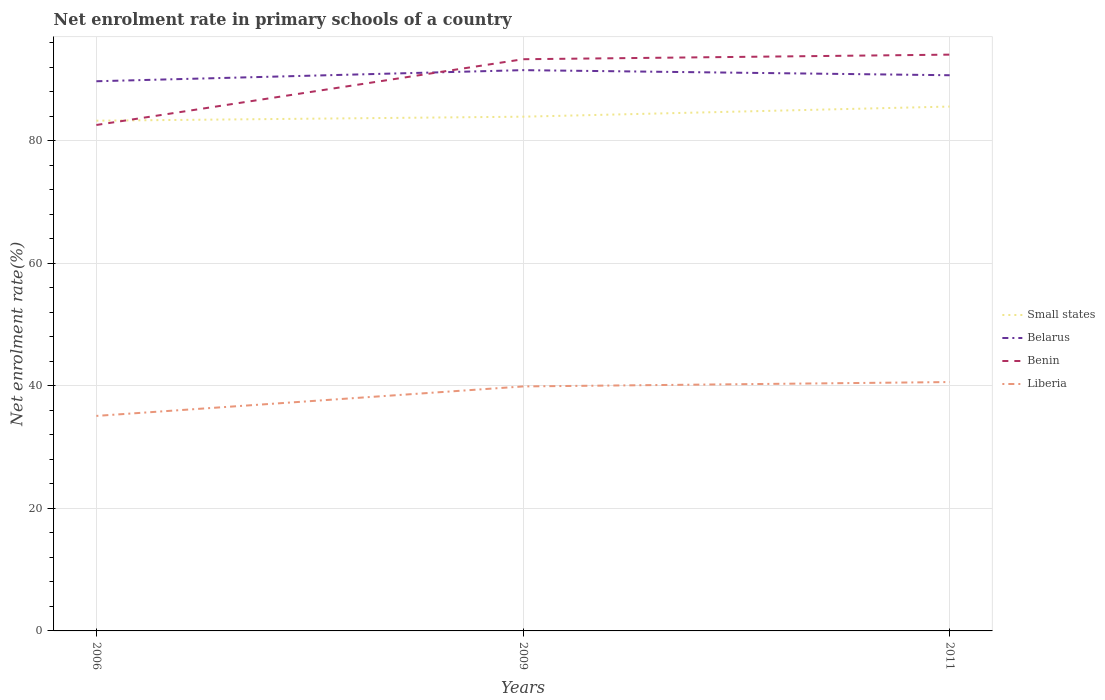How many different coloured lines are there?
Offer a terse response. 4. Does the line corresponding to Benin intersect with the line corresponding to Belarus?
Give a very brief answer. Yes. Across all years, what is the maximum net enrolment rate in primary schools in Benin?
Offer a terse response. 82.58. In which year was the net enrolment rate in primary schools in Benin maximum?
Your answer should be very brief. 2006. What is the total net enrolment rate in primary schools in Small states in the graph?
Keep it short and to the point. -1.65. What is the difference between the highest and the second highest net enrolment rate in primary schools in Benin?
Your response must be concise. 11.48. Is the net enrolment rate in primary schools in Liberia strictly greater than the net enrolment rate in primary schools in Benin over the years?
Provide a succinct answer. Yes. How many years are there in the graph?
Offer a very short reply. 3. What is the difference between two consecutive major ticks on the Y-axis?
Ensure brevity in your answer.  20. Where does the legend appear in the graph?
Ensure brevity in your answer.  Center right. How are the legend labels stacked?
Your answer should be very brief. Vertical. What is the title of the graph?
Your answer should be compact. Net enrolment rate in primary schools of a country. What is the label or title of the X-axis?
Give a very brief answer. Years. What is the label or title of the Y-axis?
Your answer should be very brief. Net enrolment rate(%). What is the Net enrolment rate(%) in Small states in 2006?
Offer a very short reply. 83.28. What is the Net enrolment rate(%) in Belarus in 2006?
Your answer should be compact. 89.72. What is the Net enrolment rate(%) of Benin in 2006?
Provide a short and direct response. 82.58. What is the Net enrolment rate(%) in Liberia in 2006?
Offer a terse response. 35.09. What is the Net enrolment rate(%) of Small states in 2009?
Your answer should be compact. 83.93. What is the Net enrolment rate(%) of Belarus in 2009?
Your answer should be very brief. 91.53. What is the Net enrolment rate(%) in Benin in 2009?
Make the answer very short. 93.31. What is the Net enrolment rate(%) in Liberia in 2009?
Give a very brief answer. 39.91. What is the Net enrolment rate(%) of Small states in 2011?
Ensure brevity in your answer.  85.59. What is the Net enrolment rate(%) of Belarus in 2011?
Ensure brevity in your answer.  90.7. What is the Net enrolment rate(%) in Benin in 2011?
Offer a very short reply. 94.06. What is the Net enrolment rate(%) in Liberia in 2011?
Give a very brief answer. 40.62. Across all years, what is the maximum Net enrolment rate(%) in Small states?
Your response must be concise. 85.59. Across all years, what is the maximum Net enrolment rate(%) in Belarus?
Your answer should be compact. 91.53. Across all years, what is the maximum Net enrolment rate(%) of Benin?
Give a very brief answer. 94.06. Across all years, what is the maximum Net enrolment rate(%) in Liberia?
Offer a terse response. 40.62. Across all years, what is the minimum Net enrolment rate(%) of Small states?
Ensure brevity in your answer.  83.28. Across all years, what is the minimum Net enrolment rate(%) of Belarus?
Your response must be concise. 89.72. Across all years, what is the minimum Net enrolment rate(%) of Benin?
Ensure brevity in your answer.  82.58. Across all years, what is the minimum Net enrolment rate(%) in Liberia?
Ensure brevity in your answer.  35.09. What is the total Net enrolment rate(%) in Small states in the graph?
Your answer should be very brief. 252.8. What is the total Net enrolment rate(%) in Belarus in the graph?
Your response must be concise. 271.95. What is the total Net enrolment rate(%) in Benin in the graph?
Your answer should be compact. 269.95. What is the total Net enrolment rate(%) in Liberia in the graph?
Offer a terse response. 115.62. What is the difference between the Net enrolment rate(%) in Small states in 2006 and that in 2009?
Make the answer very short. -0.65. What is the difference between the Net enrolment rate(%) in Belarus in 2006 and that in 2009?
Your answer should be very brief. -1.81. What is the difference between the Net enrolment rate(%) of Benin in 2006 and that in 2009?
Your answer should be compact. -10.73. What is the difference between the Net enrolment rate(%) in Liberia in 2006 and that in 2009?
Offer a terse response. -4.81. What is the difference between the Net enrolment rate(%) in Small states in 2006 and that in 2011?
Offer a very short reply. -2.31. What is the difference between the Net enrolment rate(%) of Belarus in 2006 and that in 2011?
Provide a short and direct response. -0.98. What is the difference between the Net enrolment rate(%) in Benin in 2006 and that in 2011?
Ensure brevity in your answer.  -11.48. What is the difference between the Net enrolment rate(%) of Liberia in 2006 and that in 2011?
Provide a short and direct response. -5.53. What is the difference between the Net enrolment rate(%) in Small states in 2009 and that in 2011?
Keep it short and to the point. -1.65. What is the difference between the Net enrolment rate(%) of Belarus in 2009 and that in 2011?
Offer a very short reply. 0.83. What is the difference between the Net enrolment rate(%) in Benin in 2009 and that in 2011?
Ensure brevity in your answer.  -0.75. What is the difference between the Net enrolment rate(%) of Liberia in 2009 and that in 2011?
Your response must be concise. -0.72. What is the difference between the Net enrolment rate(%) in Small states in 2006 and the Net enrolment rate(%) in Belarus in 2009?
Your response must be concise. -8.25. What is the difference between the Net enrolment rate(%) in Small states in 2006 and the Net enrolment rate(%) in Benin in 2009?
Make the answer very short. -10.03. What is the difference between the Net enrolment rate(%) in Small states in 2006 and the Net enrolment rate(%) in Liberia in 2009?
Your response must be concise. 43.37. What is the difference between the Net enrolment rate(%) of Belarus in 2006 and the Net enrolment rate(%) of Benin in 2009?
Your response must be concise. -3.6. What is the difference between the Net enrolment rate(%) in Belarus in 2006 and the Net enrolment rate(%) in Liberia in 2009?
Your answer should be very brief. 49.81. What is the difference between the Net enrolment rate(%) of Benin in 2006 and the Net enrolment rate(%) of Liberia in 2009?
Provide a succinct answer. 42.67. What is the difference between the Net enrolment rate(%) of Small states in 2006 and the Net enrolment rate(%) of Belarus in 2011?
Ensure brevity in your answer.  -7.42. What is the difference between the Net enrolment rate(%) in Small states in 2006 and the Net enrolment rate(%) in Benin in 2011?
Ensure brevity in your answer.  -10.78. What is the difference between the Net enrolment rate(%) of Small states in 2006 and the Net enrolment rate(%) of Liberia in 2011?
Ensure brevity in your answer.  42.66. What is the difference between the Net enrolment rate(%) in Belarus in 2006 and the Net enrolment rate(%) in Benin in 2011?
Your response must be concise. -4.34. What is the difference between the Net enrolment rate(%) in Belarus in 2006 and the Net enrolment rate(%) in Liberia in 2011?
Provide a succinct answer. 49.1. What is the difference between the Net enrolment rate(%) of Benin in 2006 and the Net enrolment rate(%) of Liberia in 2011?
Provide a short and direct response. 41.96. What is the difference between the Net enrolment rate(%) in Small states in 2009 and the Net enrolment rate(%) in Belarus in 2011?
Provide a short and direct response. -6.77. What is the difference between the Net enrolment rate(%) of Small states in 2009 and the Net enrolment rate(%) of Benin in 2011?
Your answer should be very brief. -10.13. What is the difference between the Net enrolment rate(%) in Small states in 2009 and the Net enrolment rate(%) in Liberia in 2011?
Offer a very short reply. 43.31. What is the difference between the Net enrolment rate(%) of Belarus in 2009 and the Net enrolment rate(%) of Benin in 2011?
Provide a short and direct response. -2.53. What is the difference between the Net enrolment rate(%) in Belarus in 2009 and the Net enrolment rate(%) in Liberia in 2011?
Provide a short and direct response. 50.91. What is the difference between the Net enrolment rate(%) in Benin in 2009 and the Net enrolment rate(%) in Liberia in 2011?
Your answer should be compact. 52.69. What is the average Net enrolment rate(%) in Small states per year?
Offer a very short reply. 84.27. What is the average Net enrolment rate(%) of Belarus per year?
Your answer should be compact. 90.65. What is the average Net enrolment rate(%) in Benin per year?
Your answer should be very brief. 89.98. What is the average Net enrolment rate(%) of Liberia per year?
Offer a very short reply. 38.54. In the year 2006, what is the difference between the Net enrolment rate(%) in Small states and Net enrolment rate(%) in Belarus?
Ensure brevity in your answer.  -6.44. In the year 2006, what is the difference between the Net enrolment rate(%) in Small states and Net enrolment rate(%) in Benin?
Provide a succinct answer. 0.7. In the year 2006, what is the difference between the Net enrolment rate(%) in Small states and Net enrolment rate(%) in Liberia?
Provide a short and direct response. 48.18. In the year 2006, what is the difference between the Net enrolment rate(%) in Belarus and Net enrolment rate(%) in Benin?
Your answer should be compact. 7.14. In the year 2006, what is the difference between the Net enrolment rate(%) in Belarus and Net enrolment rate(%) in Liberia?
Provide a succinct answer. 54.62. In the year 2006, what is the difference between the Net enrolment rate(%) of Benin and Net enrolment rate(%) of Liberia?
Offer a terse response. 47.48. In the year 2009, what is the difference between the Net enrolment rate(%) of Small states and Net enrolment rate(%) of Belarus?
Your answer should be compact. -7.6. In the year 2009, what is the difference between the Net enrolment rate(%) of Small states and Net enrolment rate(%) of Benin?
Your answer should be very brief. -9.38. In the year 2009, what is the difference between the Net enrolment rate(%) of Small states and Net enrolment rate(%) of Liberia?
Provide a succinct answer. 44.03. In the year 2009, what is the difference between the Net enrolment rate(%) in Belarus and Net enrolment rate(%) in Benin?
Ensure brevity in your answer.  -1.78. In the year 2009, what is the difference between the Net enrolment rate(%) of Belarus and Net enrolment rate(%) of Liberia?
Make the answer very short. 51.62. In the year 2009, what is the difference between the Net enrolment rate(%) of Benin and Net enrolment rate(%) of Liberia?
Keep it short and to the point. 53.41. In the year 2011, what is the difference between the Net enrolment rate(%) of Small states and Net enrolment rate(%) of Belarus?
Your answer should be very brief. -5.11. In the year 2011, what is the difference between the Net enrolment rate(%) of Small states and Net enrolment rate(%) of Benin?
Ensure brevity in your answer.  -8.47. In the year 2011, what is the difference between the Net enrolment rate(%) of Small states and Net enrolment rate(%) of Liberia?
Provide a succinct answer. 44.97. In the year 2011, what is the difference between the Net enrolment rate(%) in Belarus and Net enrolment rate(%) in Benin?
Make the answer very short. -3.36. In the year 2011, what is the difference between the Net enrolment rate(%) of Belarus and Net enrolment rate(%) of Liberia?
Provide a short and direct response. 50.08. In the year 2011, what is the difference between the Net enrolment rate(%) of Benin and Net enrolment rate(%) of Liberia?
Your answer should be very brief. 53.44. What is the ratio of the Net enrolment rate(%) in Belarus in 2006 to that in 2009?
Give a very brief answer. 0.98. What is the ratio of the Net enrolment rate(%) in Benin in 2006 to that in 2009?
Provide a succinct answer. 0.89. What is the ratio of the Net enrolment rate(%) in Liberia in 2006 to that in 2009?
Your answer should be compact. 0.88. What is the ratio of the Net enrolment rate(%) in Small states in 2006 to that in 2011?
Keep it short and to the point. 0.97. What is the ratio of the Net enrolment rate(%) of Belarus in 2006 to that in 2011?
Your response must be concise. 0.99. What is the ratio of the Net enrolment rate(%) in Benin in 2006 to that in 2011?
Give a very brief answer. 0.88. What is the ratio of the Net enrolment rate(%) in Liberia in 2006 to that in 2011?
Provide a succinct answer. 0.86. What is the ratio of the Net enrolment rate(%) in Small states in 2009 to that in 2011?
Offer a terse response. 0.98. What is the ratio of the Net enrolment rate(%) in Belarus in 2009 to that in 2011?
Offer a terse response. 1.01. What is the ratio of the Net enrolment rate(%) of Liberia in 2009 to that in 2011?
Your answer should be compact. 0.98. What is the difference between the highest and the second highest Net enrolment rate(%) of Small states?
Your answer should be compact. 1.65. What is the difference between the highest and the second highest Net enrolment rate(%) of Belarus?
Offer a terse response. 0.83. What is the difference between the highest and the second highest Net enrolment rate(%) of Benin?
Provide a succinct answer. 0.75. What is the difference between the highest and the second highest Net enrolment rate(%) in Liberia?
Provide a short and direct response. 0.72. What is the difference between the highest and the lowest Net enrolment rate(%) in Small states?
Offer a very short reply. 2.31. What is the difference between the highest and the lowest Net enrolment rate(%) in Belarus?
Provide a short and direct response. 1.81. What is the difference between the highest and the lowest Net enrolment rate(%) of Benin?
Your answer should be compact. 11.48. What is the difference between the highest and the lowest Net enrolment rate(%) in Liberia?
Your answer should be compact. 5.53. 